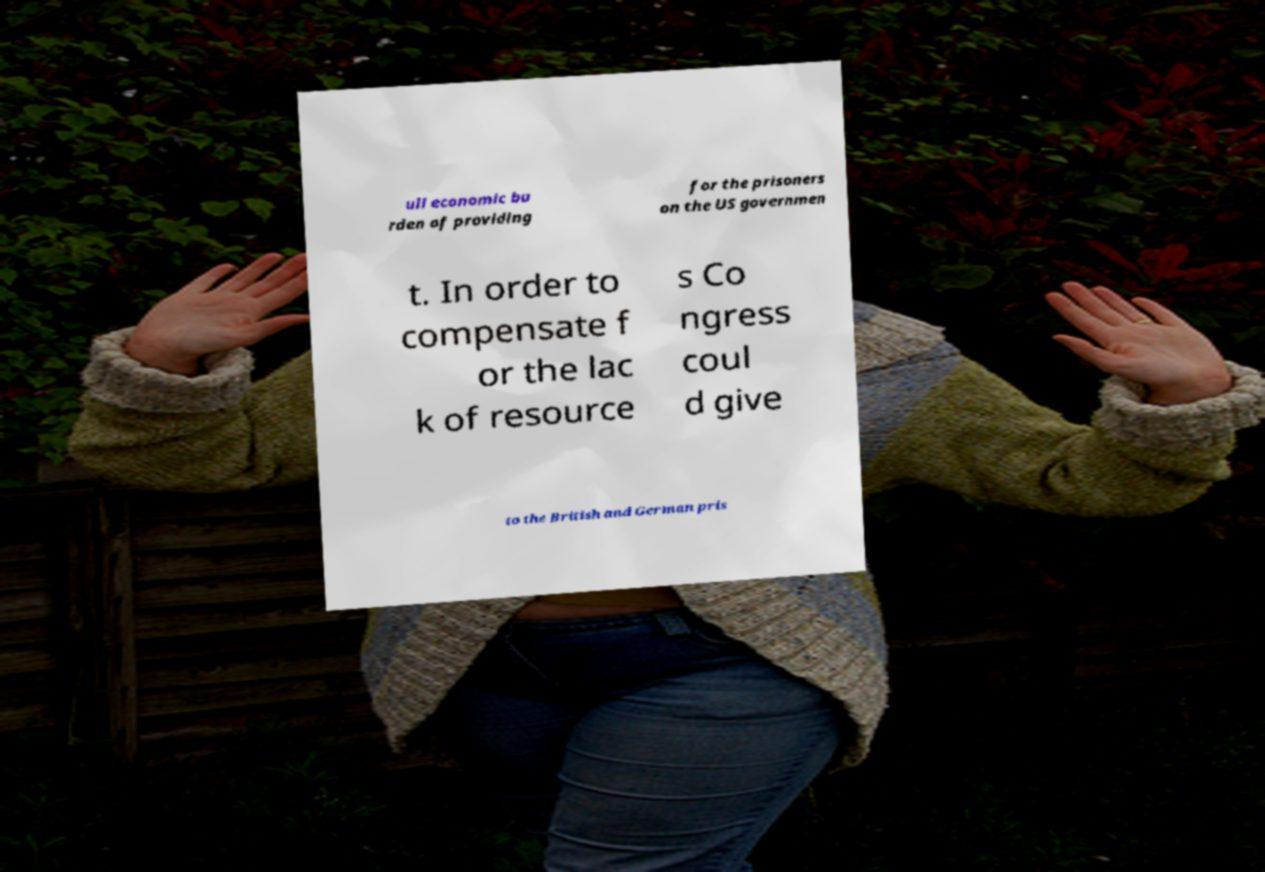There's text embedded in this image that I need extracted. Can you transcribe it verbatim? ull economic bu rden of providing for the prisoners on the US governmen t. In order to compensate f or the lac k of resource s Co ngress coul d give to the British and German pris 